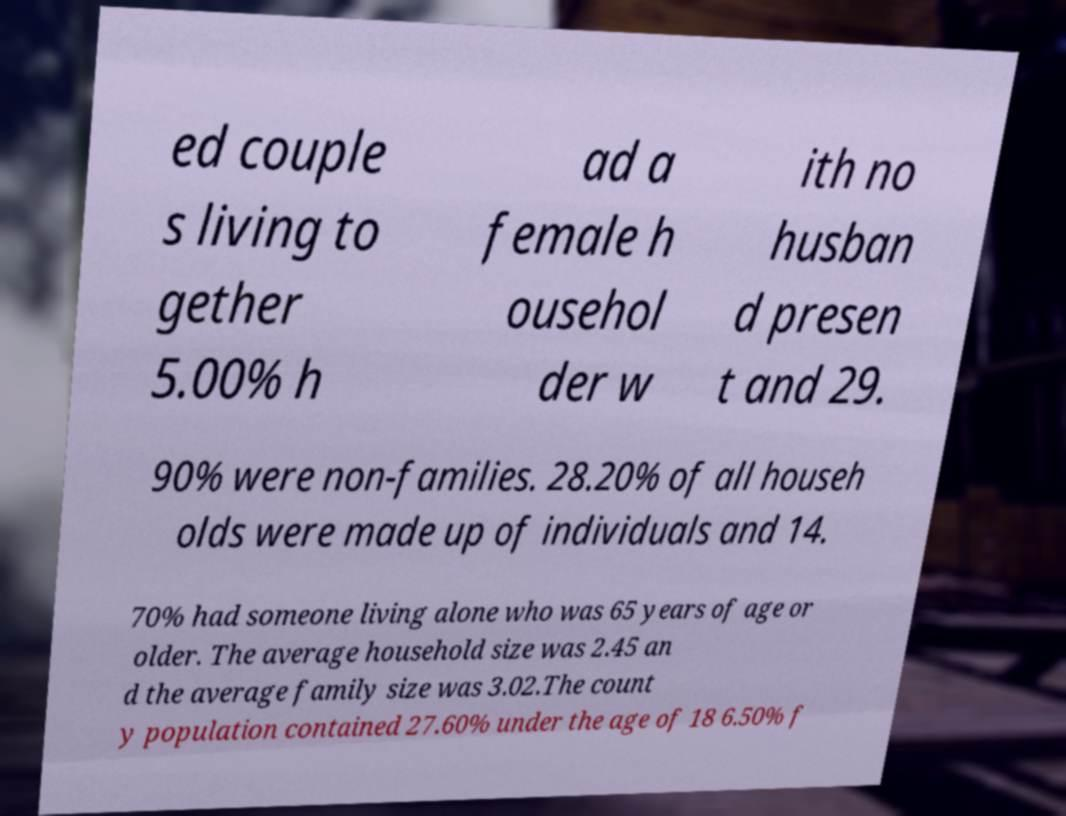What messages or text are displayed in this image? I need them in a readable, typed format. ed couple s living to gether 5.00% h ad a female h ousehol der w ith no husban d presen t and 29. 90% were non-families. 28.20% of all househ olds were made up of individuals and 14. 70% had someone living alone who was 65 years of age or older. The average household size was 2.45 an d the average family size was 3.02.The count y population contained 27.60% under the age of 18 6.50% f 